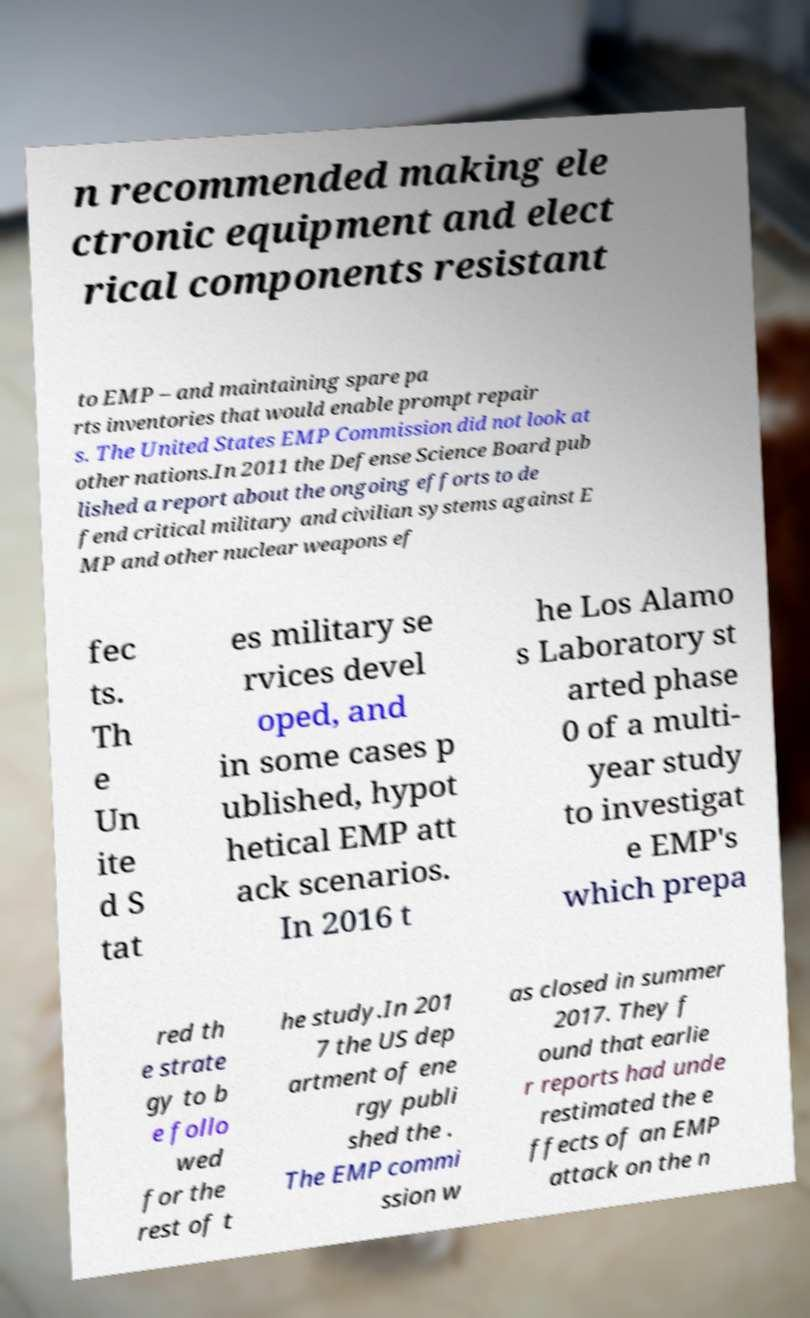Please identify and transcribe the text found in this image. n recommended making ele ctronic equipment and elect rical components resistant to EMP – and maintaining spare pa rts inventories that would enable prompt repair s. The United States EMP Commission did not look at other nations.In 2011 the Defense Science Board pub lished a report about the ongoing efforts to de fend critical military and civilian systems against E MP and other nuclear weapons ef fec ts. Th e Un ite d S tat es military se rvices devel oped, and in some cases p ublished, hypot hetical EMP att ack scenarios. In 2016 t he Los Alamo s Laboratory st arted phase 0 of a multi- year study to investigat e EMP's which prepa red th e strate gy to b e follo wed for the rest of t he study.In 201 7 the US dep artment of ene rgy publi shed the . The EMP commi ssion w as closed in summer 2017. They f ound that earlie r reports had unde restimated the e ffects of an EMP attack on the n 